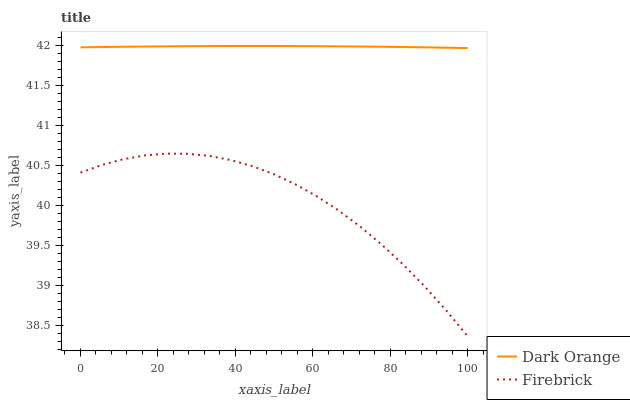Does Firebrick have the minimum area under the curve?
Answer yes or no. Yes. Does Dark Orange have the maximum area under the curve?
Answer yes or no. Yes. Does Firebrick have the maximum area under the curve?
Answer yes or no. No. Is Dark Orange the smoothest?
Answer yes or no. Yes. Is Firebrick the roughest?
Answer yes or no. Yes. Is Firebrick the smoothest?
Answer yes or no. No. Does Firebrick have the lowest value?
Answer yes or no. Yes. Does Dark Orange have the highest value?
Answer yes or no. Yes. Does Firebrick have the highest value?
Answer yes or no. No. Is Firebrick less than Dark Orange?
Answer yes or no. Yes. Is Dark Orange greater than Firebrick?
Answer yes or no. Yes. Does Firebrick intersect Dark Orange?
Answer yes or no. No. 